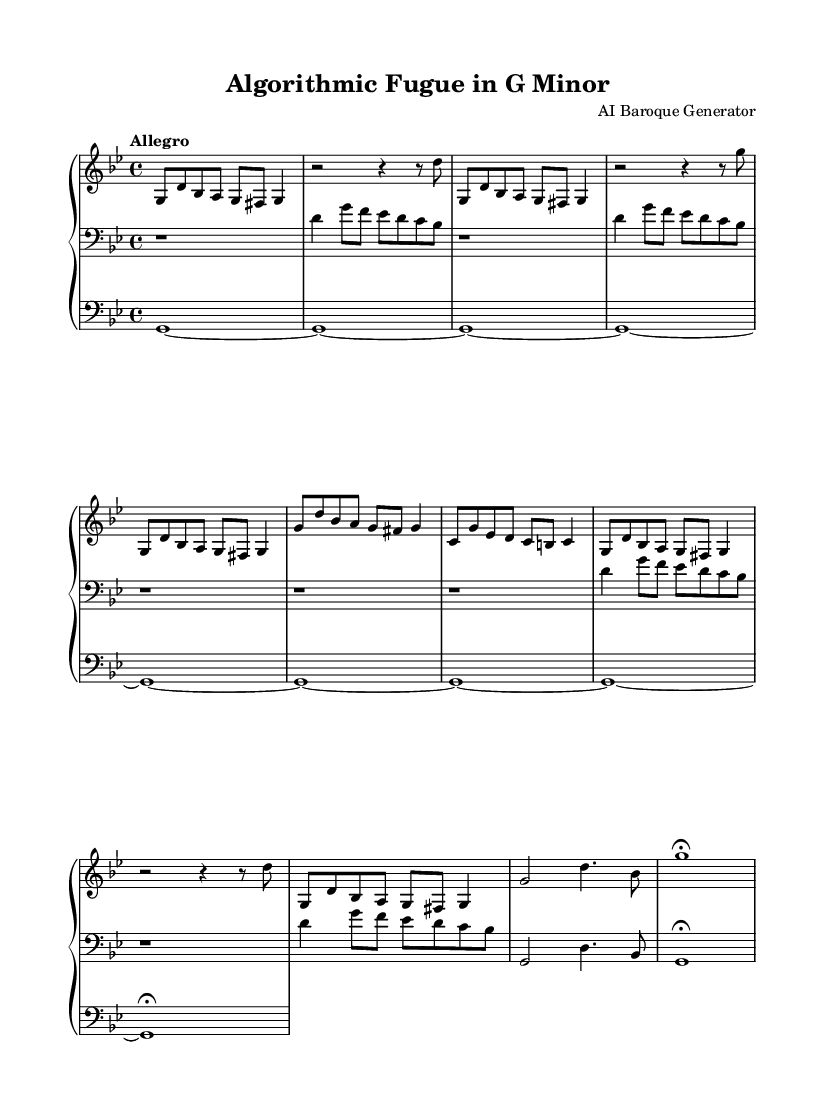What is the key signature of this music? The key signature is G minor, as indicated by the two flats (B flat and E flat) in the key signature at the beginning of the score.
Answer: G minor What is the time signature of this piece? The time signature at the beginning of the score is 4/4, which is clearly indicated. This means there are four beats in each measure.
Answer: 4/4 What is the tempo marking for this fugue? The tempo marking is "Allegro", which suggests a fast and lively speed for performance, stated clearly at the start of the piece.
Answer: Allegro How many times is the main motif repeated in the exposition section? The main motif is repeated three times in the exposition section, as can be observed in the upper part where it appears consecutively.
Answer: Three What is the dynamics marking at the end of the piece? There are no explicit dynamics markings at the end, but the final note is marked with a fermata, indicating it should be held beyond its usual duration for expression.
Answer: Fermata Which compositional technique is predominantly used in this piece? The piece prominently utilizes the technique of repetition, as shown by the recursive nature of the main motif and counter subject throughout the composition.
Answer: Repetition What is the texture of this fugue? The texture is polyphonic, as multiple independent melodic lines are woven together, particularly evident in the interplay between the upper and lower parts.
Answer: Polyphonic 